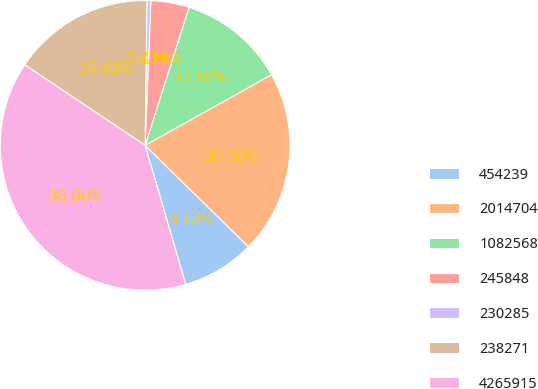<chart> <loc_0><loc_0><loc_500><loc_500><pie_chart><fcel>454239<fcel>2014704<fcel>1082568<fcel>245848<fcel>230285<fcel>238271<fcel>4265915<nl><fcel>8.13%<fcel>20.46%<fcel>11.97%<fcel>4.28%<fcel>0.43%<fcel>15.82%<fcel>38.9%<nl></chart> 